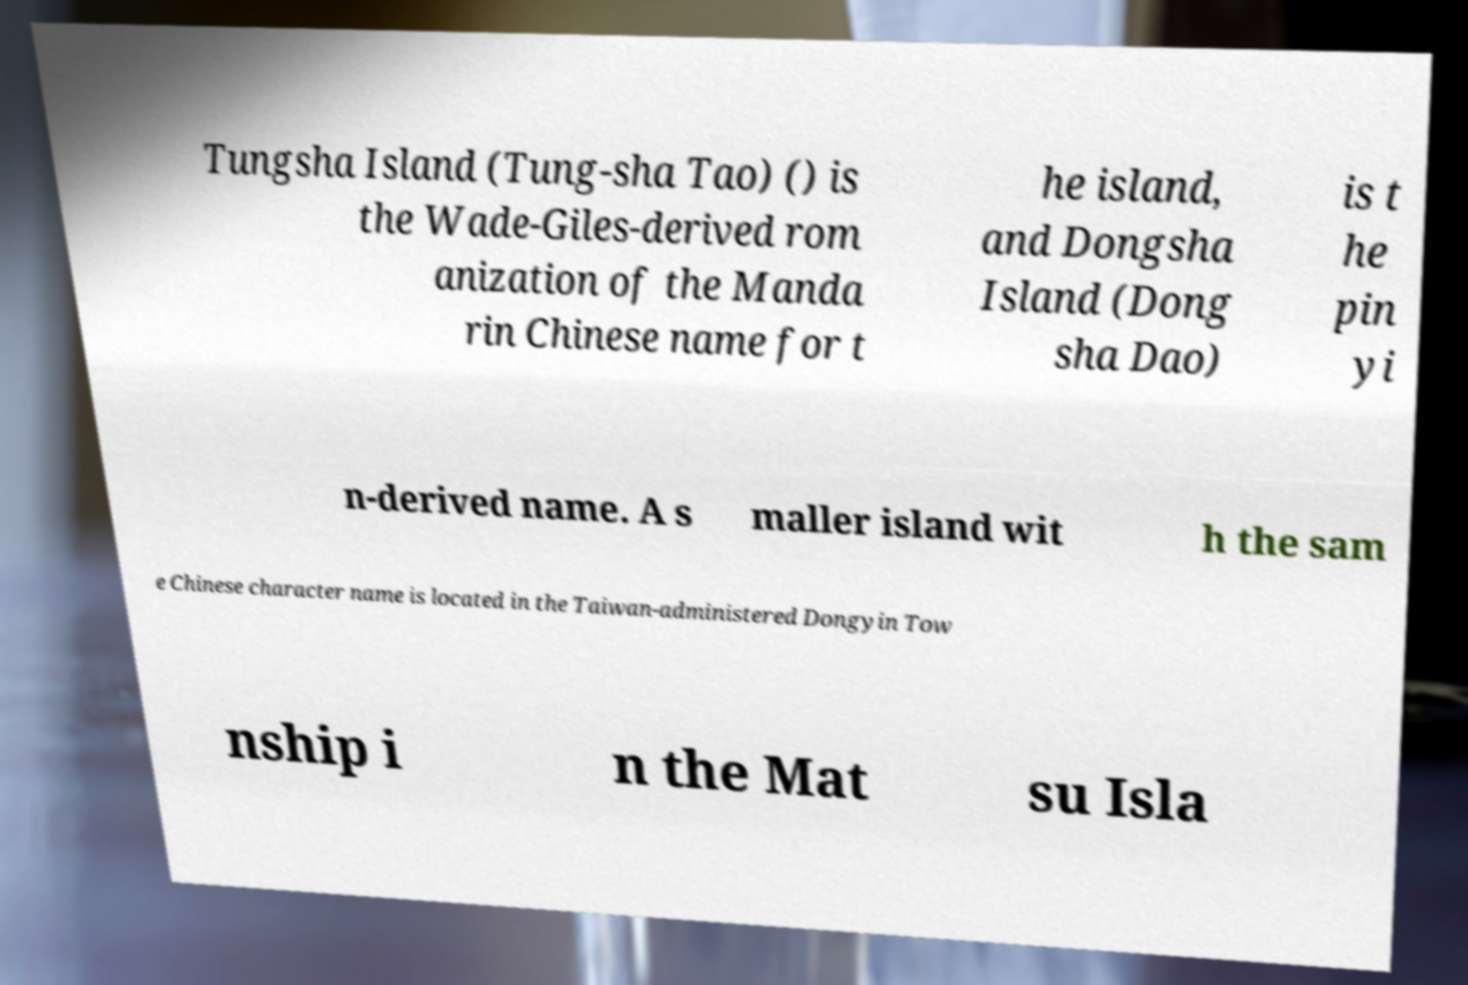For documentation purposes, I need the text within this image transcribed. Could you provide that? Tungsha Island (Tung-sha Tao) () is the Wade-Giles-derived rom anization of the Manda rin Chinese name for t he island, and Dongsha Island (Dong sha Dao) is t he pin yi n-derived name. A s maller island wit h the sam e Chinese character name is located in the Taiwan-administered Dongyin Tow nship i n the Mat su Isla 